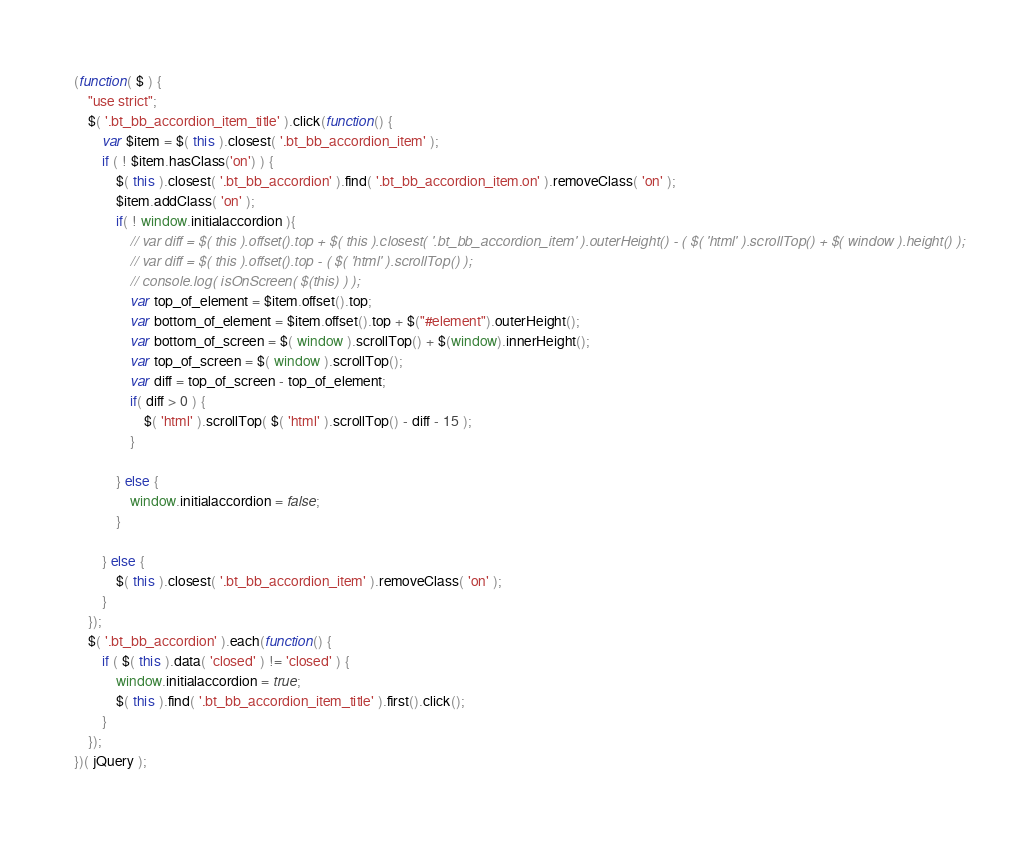<code> <loc_0><loc_0><loc_500><loc_500><_JavaScript_>(function( $ ) {
	"use strict";
	$( '.bt_bb_accordion_item_title' ).click(function() {
		var $item = $( this ).closest( '.bt_bb_accordion_item' );
		if ( ! $item.hasClass('on') ) {
			$( this ).closest( '.bt_bb_accordion' ).find( '.bt_bb_accordion_item.on' ).removeClass( 'on' );
			$item.addClass( 'on' );
			if( ! window.initialaccordion ){
				// var diff = $( this ).offset().top + $( this ).closest( '.bt_bb_accordion_item' ).outerHeight() - ( $( 'html' ).scrollTop() + $( window ).height() );
				// var diff = $( this ).offset().top - ( $( 'html' ).scrollTop() );
				// console.log( isOnScreen( $(this) ) );    
				var top_of_element = $item.offset().top;
				var bottom_of_element = $item.offset().top + $("#element").outerHeight();
				var bottom_of_screen = $( window ).scrollTop() + $(window).innerHeight();
				var top_of_screen = $( window ).scrollTop();
				var diff = top_of_screen - top_of_element;
				if( diff > 0 ) {
					$( 'html' ).scrollTop( $( 'html' ).scrollTop() - diff - 15 );
				}

			} else {
				window.initialaccordion = false;
			}
		
		} else {
			$( this ).closest( '.bt_bb_accordion_item' ).removeClass( 'on' );
		}
	});
	$( '.bt_bb_accordion' ).each(function() {
		if ( $( this ).data( 'closed' ) != 'closed' ) {
			window.initialaccordion = true;
			$( this ).find( '.bt_bb_accordion_item_title' ).first().click();
		}
	});
})( jQuery );</code> 